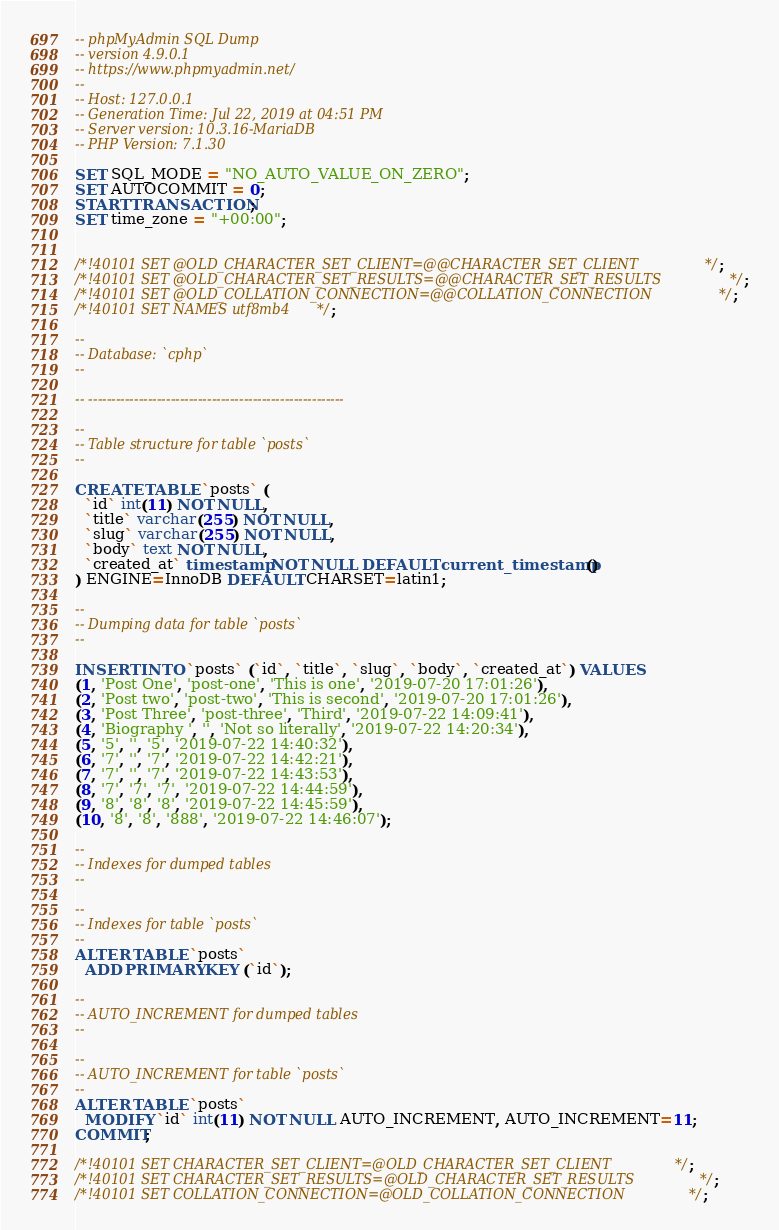<code> <loc_0><loc_0><loc_500><loc_500><_SQL_>-- phpMyAdmin SQL Dump
-- version 4.9.0.1
-- https://www.phpmyadmin.net/
--
-- Host: 127.0.0.1
-- Generation Time: Jul 22, 2019 at 04:51 PM
-- Server version: 10.3.16-MariaDB
-- PHP Version: 7.1.30

SET SQL_MODE = "NO_AUTO_VALUE_ON_ZERO";
SET AUTOCOMMIT = 0;
START TRANSACTION;
SET time_zone = "+00:00";


/*!40101 SET @OLD_CHARACTER_SET_CLIENT=@@CHARACTER_SET_CLIENT */;
/*!40101 SET @OLD_CHARACTER_SET_RESULTS=@@CHARACTER_SET_RESULTS */;
/*!40101 SET @OLD_COLLATION_CONNECTION=@@COLLATION_CONNECTION */;
/*!40101 SET NAMES utf8mb4 */;

--
-- Database: `cphp`
--

-- --------------------------------------------------------

--
-- Table structure for table `posts`
--

CREATE TABLE `posts` (
  `id` int(11) NOT NULL,
  `title` varchar(255) NOT NULL,
  `slug` varchar(255) NOT NULL,
  `body` text NOT NULL,
  `created_at` timestamp NOT NULL DEFAULT current_timestamp()
) ENGINE=InnoDB DEFAULT CHARSET=latin1;

--
-- Dumping data for table `posts`
--

INSERT INTO `posts` (`id`, `title`, `slug`, `body`, `created_at`) VALUES
(1, 'Post One', 'post-one', 'This is one', '2019-07-20 17:01:26'),
(2, 'Post two', 'post-two', 'This is second', '2019-07-20 17:01:26'),
(3, 'Post Three', 'post-three', 'Third', '2019-07-22 14:09:41'),
(4, 'Biography ', '', 'Not so literally', '2019-07-22 14:20:34'),
(5, '5', '', '5', '2019-07-22 14:40:32'),
(6, '7', '', '7', '2019-07-22 14:42:21'),
(7, '7', '', '7', '2019-07-22 14:43:53'),
(8, '7', '7', '7', '2019-07-22 14:44:59'),
(9, '8', '8', '8', '2019-07-22 14:45:59'),
(10, '8', '8', '888', '2019-07-22 14:46:07');

--
-- Indexes for dumped tables
--

--
-- Indexes for table `posts`
--
ALTER TABLE `posts`
  ADD PRIMARY KEY (`id`);

--
-- AUTO_INCREMENT for dumped tables
--

--
-- AUTO_INCREMENT for table `posts`
--
ALTER TABLE `posts`
  MODIFY `id` int(11) NOT NULL AUTO_INCREMENT, AUTO_INCREMENT=11;
COMMIT;

/*!40101 SET CHARACTER_SET_CLIENT=@OLD_CHARACTER_SET_CLIENT */;
/*!40101 SET CHARACTER_SET_RESULTS=@OLD_CHARACTER_SET_RESULTS */;
/*!40101 SET COLLATION_CONNECTION=@OLD_COLLATION_CONNECTION */;
</code> 